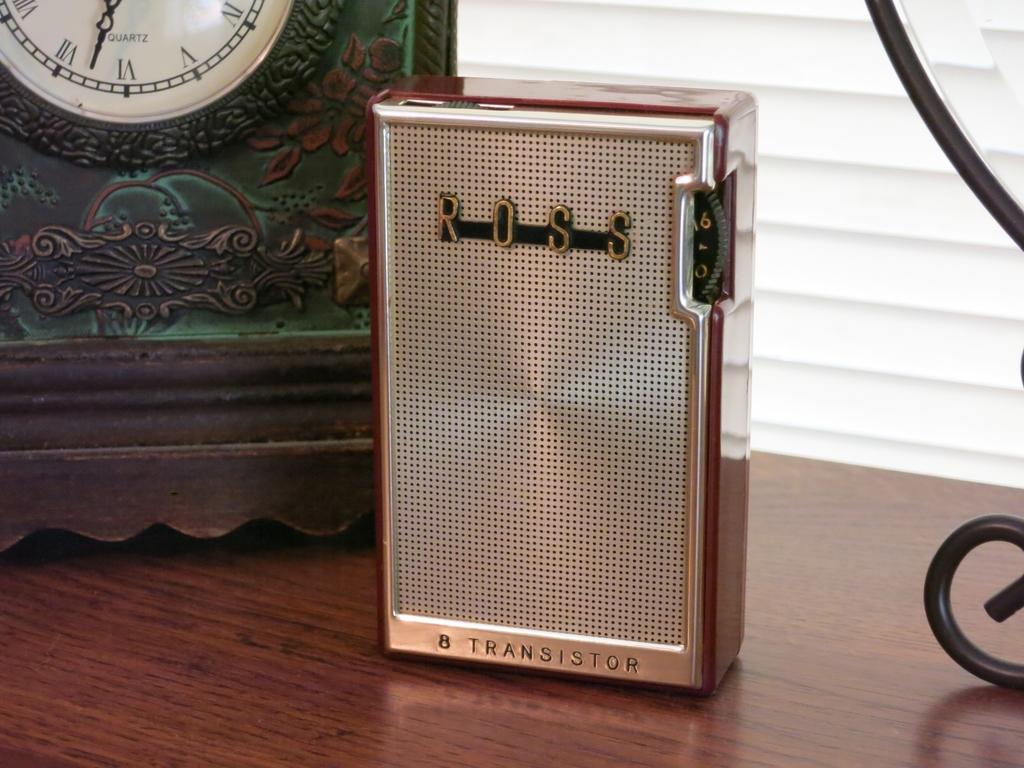What is this ross product?
Ensure brevity in your answer.  Transistor. 